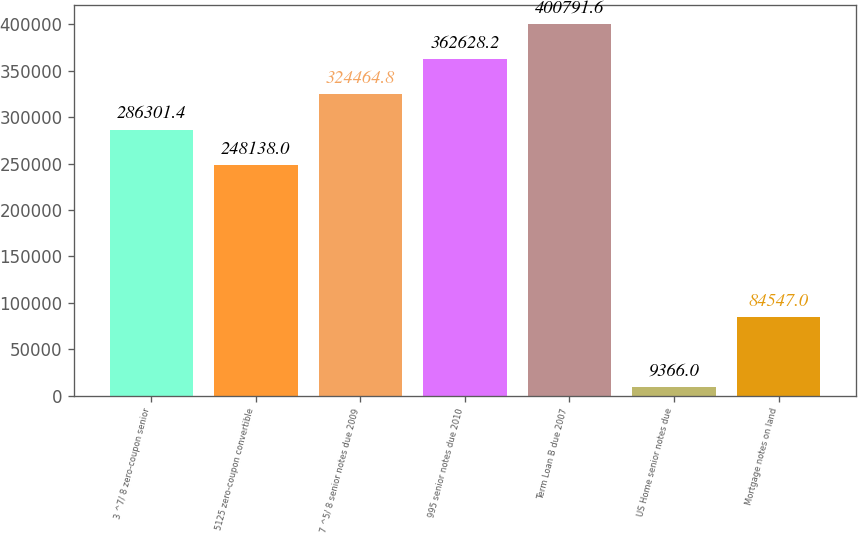<chart> <loc_0><loc_0><loc_500><loc_500><bar_chart><fcel>3 ^7/ 8 zero-coupon senior<fcel>5125 zero-coupon convertible<fcel>7 ^5/ 8 senior notes due 2009<fcel>995 senior notes due 2010<fcel>Term Loan B due 2007<fcel>US Home senior notes due<fcel>Mortgage notes on land<nl><fcel>286301<fcel>248138<fcel>324465<fcel>362628<fcel>400792<fcel>9366<fcel>84547<nl></chart> 